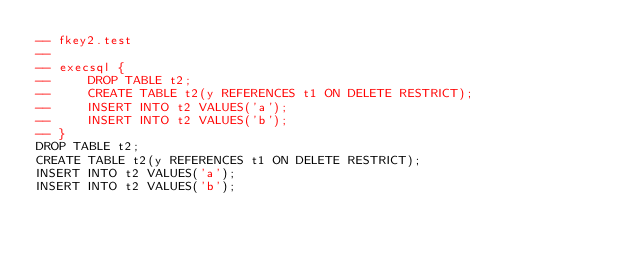<code> <loc_0><loc_0><loc_500><loc_500><_SQL_>-- fkey2.test
-- 
-- execsql {
--     DROP TABLE t2;
--     CREATE TABLE t2(y REFERENCES t1 ON DELETE RESTRICT);
--     INSERT INTO t2 VALUES('a');
--     INSERT INTO t2 VALUES('b');
-- }
DROP TABLE t2;
CREATE TABLE t2(y REFERENCES t1 ON DELETE RESTRICT);
INSERT INTO t2 VALUES('a');
INSERT INTO t2 VALUES('b');</code> 